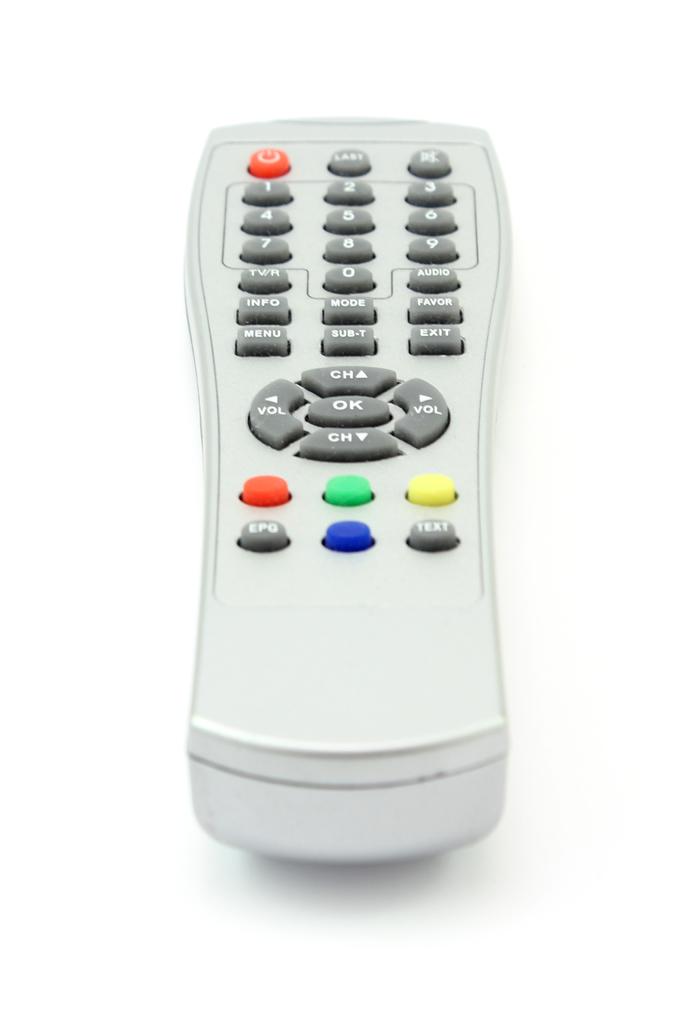What button is in the center of the circle?
Keep it short and to the point. Ok. 